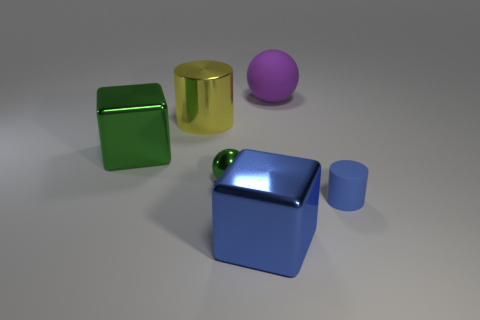Can you describe the lighting setup based on the shadows and highlights observed in the image? The lighting in the image appears to come from a source above and slightly to the right of the frame. This is indicated by the shadows cast to the left of the objects and the concentrated highlights on the top right edges of the objects. The soft edges of the shadows suggest that the light source is broad or diffuse, not highly focused. Furthermore, the intensity of the highlights, particularly on the reflective surfaces, points to a moderately strong light source. 